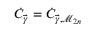Convert formula to latex. <formula><loc_0><loc_0><loc_500><loc_500>\dot { C } _ { \vec { \gamma } } = \dot { C } _ { \vec { \gamma } , \mathcal { M } _ { 2 n } }</formula> 